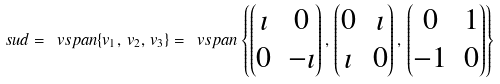<formula> <loc_0><loc_0><loc_500><loc_500>\ s u d = \ v s p a n \{ v _ { 1 } , \, v _ { 2 } , \, v _ { 3 } \} = \ v s p a n \left \{ \begin{pmatrix} \imath & 0 \\ 0 & - \imath \end{pmatrix} , \, \begin{pmatrix} 0 & \imath \\ \imath & 0 \end{pmatrix} , \, \begin{pmatrix} 0 & 1 \\ - 1 & 0 \end{pmatrix} \right \}</formula> 